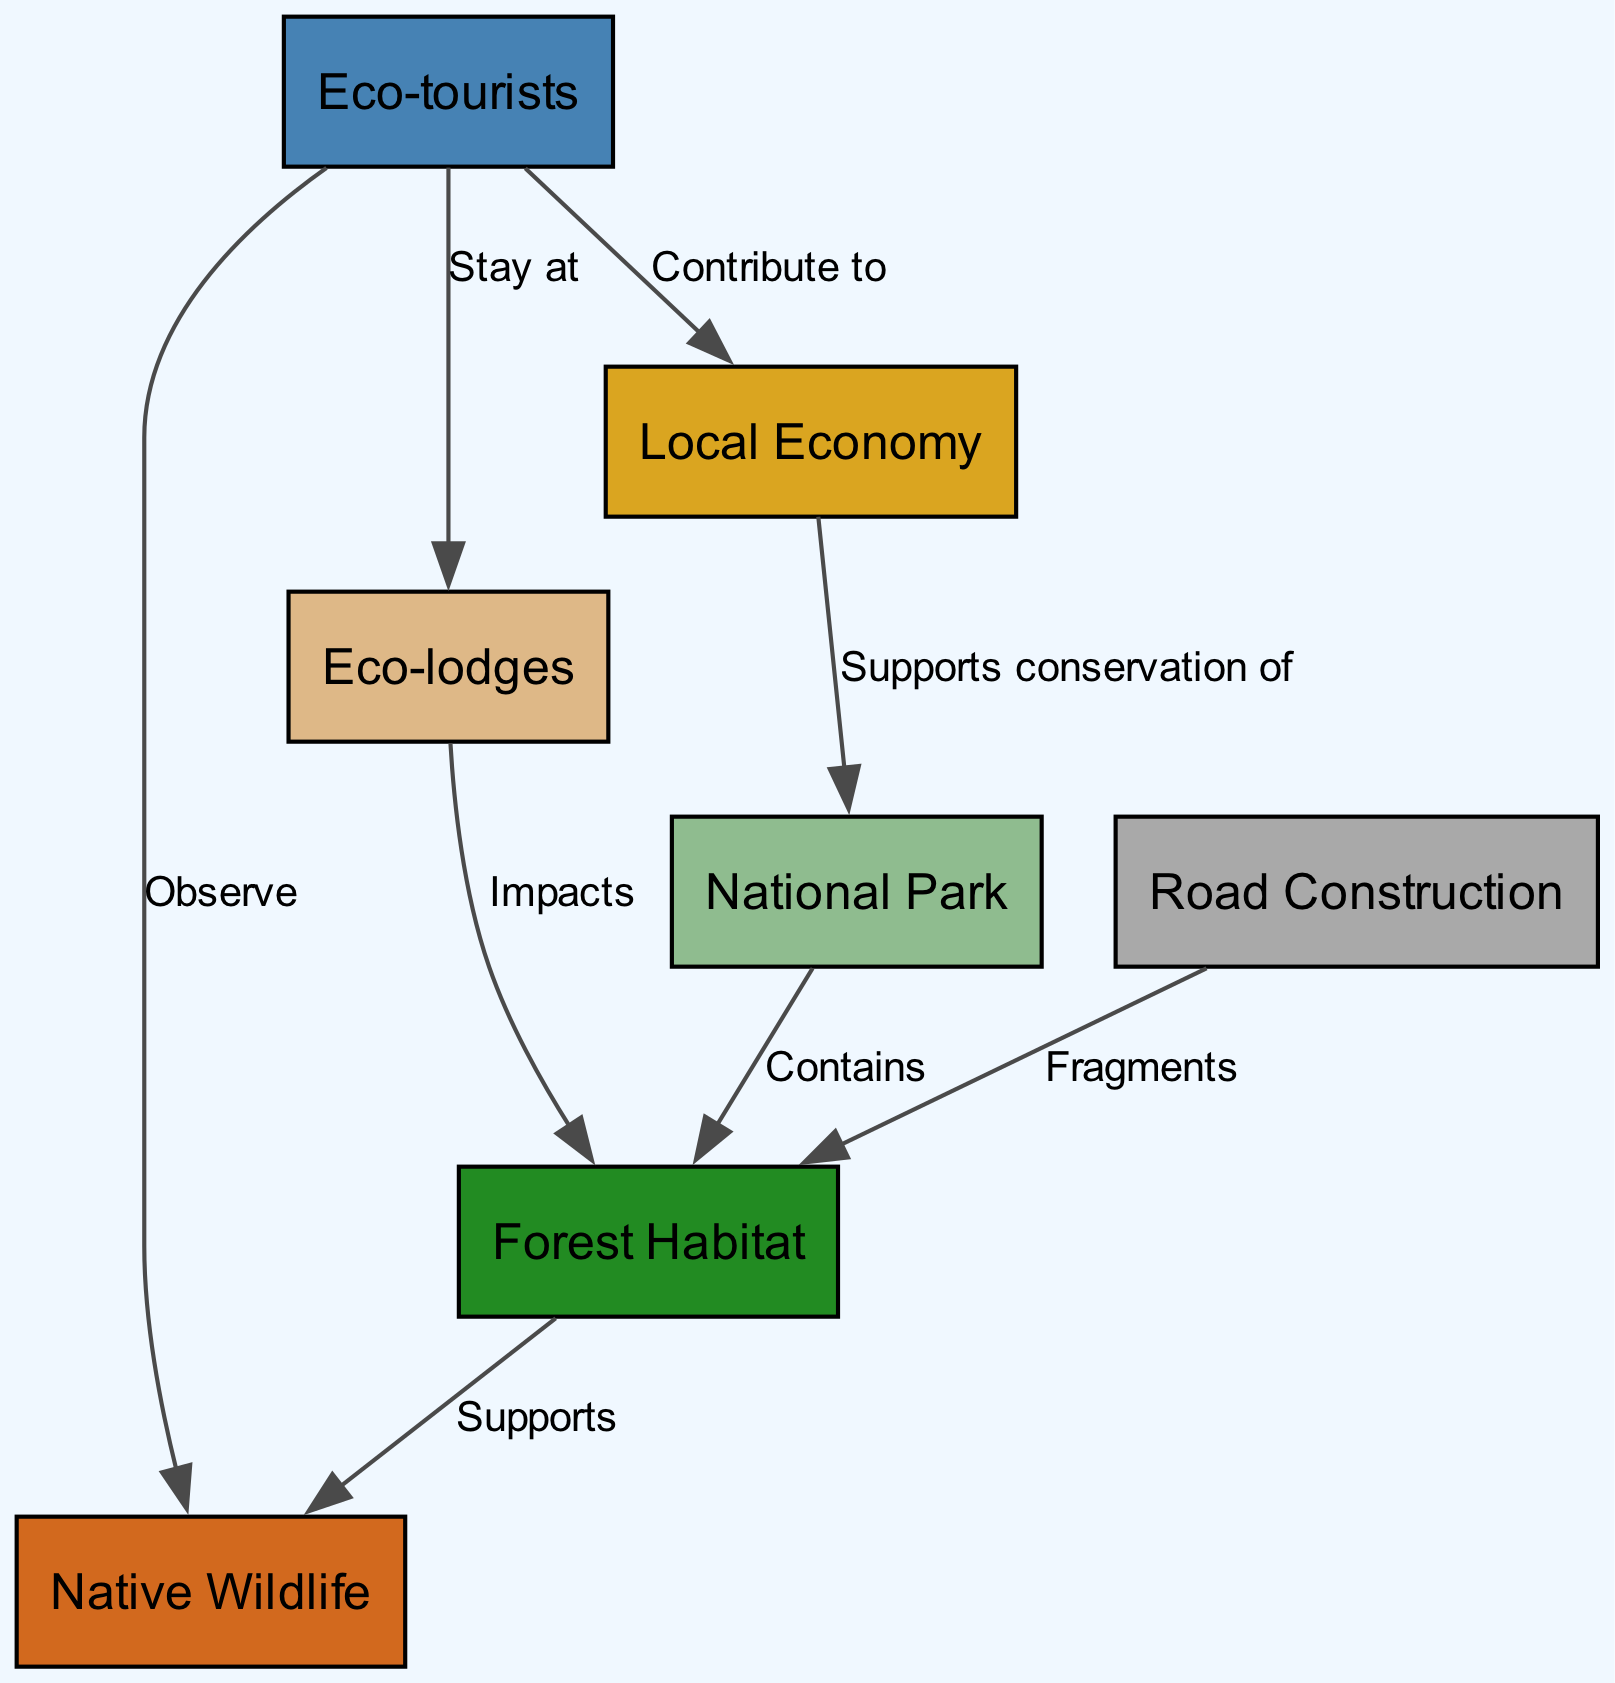What is the main habitat represented in the diagram? The main habitat in the diagram is labeled as "Forest Habitat," which is connected to the "National Park." This is the primary area that supports the native wildlife and is depicted as a key component.
Answer: Forest Habitat How many nodes are illustrated in the diagram? The diagram contains a total of seven nodes, which include National Park, Forest Habitat, Native Wildlife, Road Construction, Eco-lodges, Eco-tourists, and Local Economy. Each of these represents a different aspect of the ecosystem and human interaction.
Answer: 7 What is the relationship between Eco-tourists and Eco-lodges? The relationship between Eco-tourists and Eco-lodges is depicted as "Stay at," illustrating that eco-tourists directly interact with and utilize the eco-lodges for accommodation during their visits. This shows the connection between tourism and lodging in the area.
Answer: Stay at Which element impacts the Forest Habitat? The element that impacts the Forest Habitat is labeled as "Eco-lodges." This indicates that the establishment of eco-lodges has a direct effect on the natural habitat, potentially leading to changes in the ecosystem or habitat disruption.
Answer: Eco-lodges How do Eco-tourists contribute to the Local Economy? Eco-tourists contribute to the Local Economy through the labeled connection "Contribute to." This means that the presence of eco-tourists brings financial support and resources to the local community, which can benefit businesses and conservation efforts within the park.
Answer: Contribute to What is fractured by road construction? Road construction is shown to “Fragments” the Forest Habitat. This highlights the negative impact of infrastructure development on the natural environment by breaking up the continuity of the habitat, which can affect wildlife movement and ecosystem stability.
Answer: Forest Habitat How does the Local Economy support the National Park? The Local Economy supports the National Park through the connection labeled "Supports conservation of." This indicates that the economic activities generated by tourism and other local businesses provide necessary funding and resources for the preservation and conservation of the park's ecosystem.
Answer: Supports conservation of 